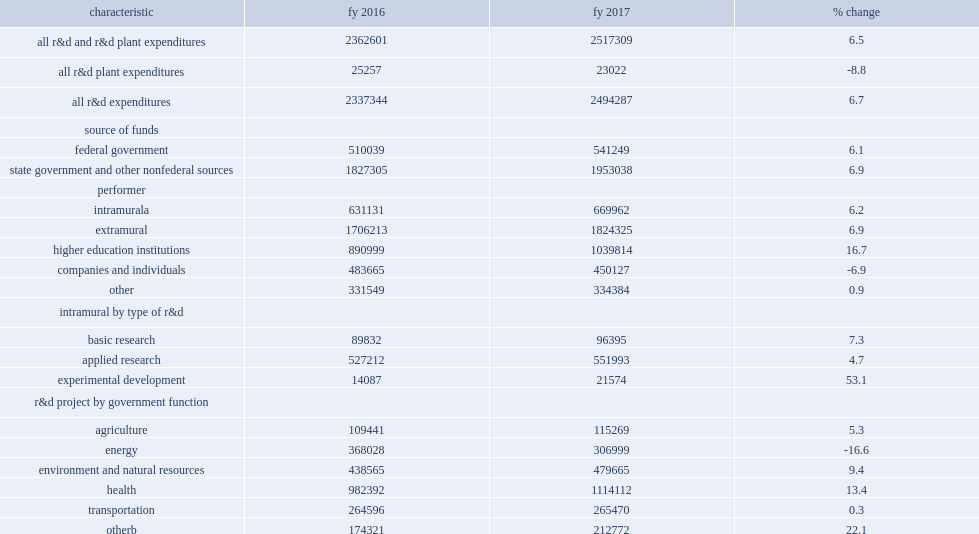How many thousand dollars did state government agency expenditures for research and development total in fy 2017? 2517309.0. State government agency expenditures for research and development totaled $2.5 billion in fy 2017, what was an increase from fy 2016? 6.5. 